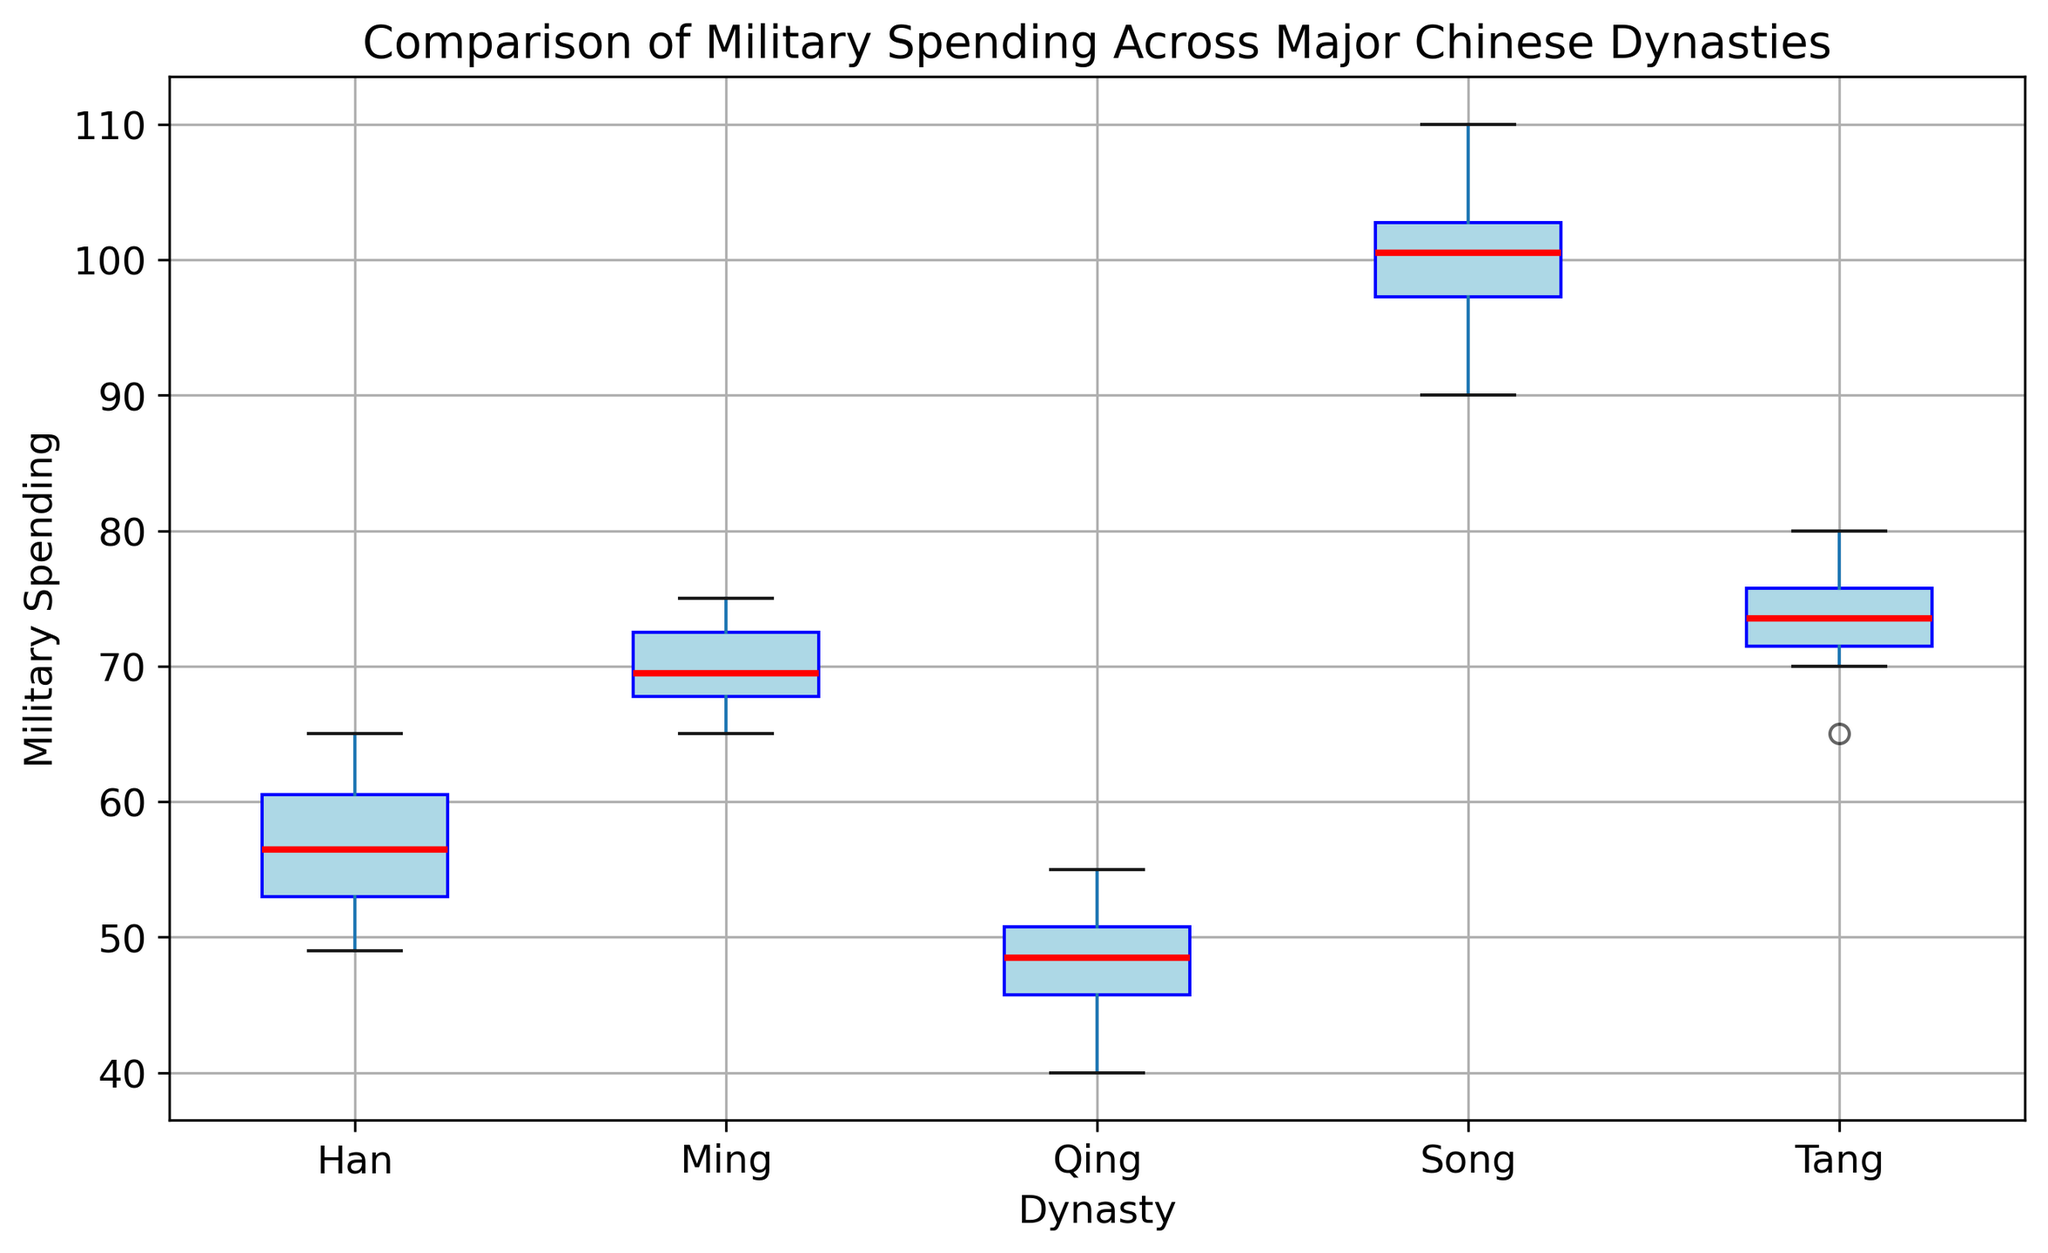Which dynasty has the highest median military spending? Look at the red line inside each box plot, which represents the median. The Song Dynasty's median line is the highest among all the dynasties.
Answer: Song What is the interquartile range (IQR) for the Han dynasty's military spending? The IQR is the difference between the third quartile (Q3) and the first quartile (Q1). For the Han dynasty, Q3 is around 61 and Q1 is around 53, so the IQR is 61 - 53.
Answer: 8 Between which two dynasties is there the largest difference in median military spending? Examine the red lines (medians) for each dynasty's box plot. The Song Dynasty has the highest median, and the Qing Dynasty has the lowest. The difference between their medians is the largest.
Answer: Song and Qing Look at the visual representation of the Tang dynasty's box plot. Does it have any outliers, and if so, how are they visually represented? Outliers are represented by yellow circles. There are no yellow circles visible in the Tang dynasty's box plot, so there are no outliers.
Answer: No Which dynasty shows the greatest variability in military spending based on the size of the box plot? The size of the box (from the first quartile to the third quartile) indicates variability. The Song Dynasty has the largest box, indicating the greatest variability.
Answer: Song How does the median military spending of the Ming dynasty compare to the Tang dynasty? Compare the red median lines of both dynasties' box plots. The Ming dynasty's median is lower than the Tang dynasty.
Answer: Ming is lower What does the color blue represent in the box plot? The color blue fills and outlines the boxes in the box plot. This represents the range of military spending from the first quartile to the third quartile for each dynasty.
Answer: Range from Q1 to Q3 Which dynasty had the lowest minimum military spending? The bottom whisker of each box plot represents the minimum value. The Qing dynasty's bottom whisker is the lowest among all dynasties.
Answer: Qing Estimate the range of military spending for the Tang dynasty based on the plot. The range is the difference between the maximum and minimum values. For the Tang dynasty, the minimum is around 65, and the maximum is around 80, so the range is 80 - 65.
Answer: 15 Which dynasty shows less variability in spending, Qing or Han, and how can you tell? The size of the box and length of the whiskers represent variability. The Qing dynasty has a smaller box and shorter whiskers compared to the Han dynasty, indicating less variability.
Answer: Qing 